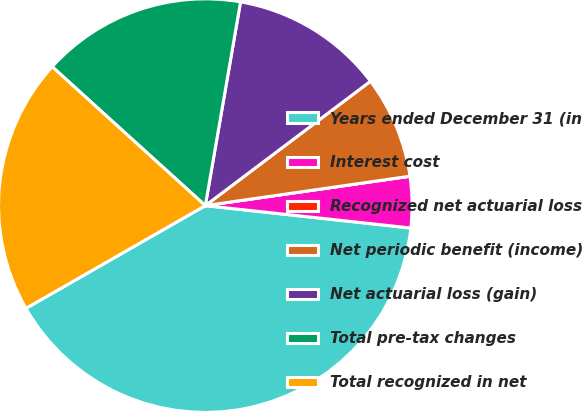Convert chart. <chart><loc_0><loc_0><loc_500><loc_500><pie_chart><fcel>Years ended December 31 (in<fcel>Interest cost<fcel>Recognized net actuarial loss<fcel>Net periodic benefit (income)<fcel>Net actuarial loss (gain)<fcel>Total pre-tax changes<fcel>Total recognized in net<nl><fcel>39.99%<fcel>4.0%<fcel>0.0%<fcel>8.0%<fcel>12.0%<fcel>16.0%<fcel>20.0%<nl></chart> 